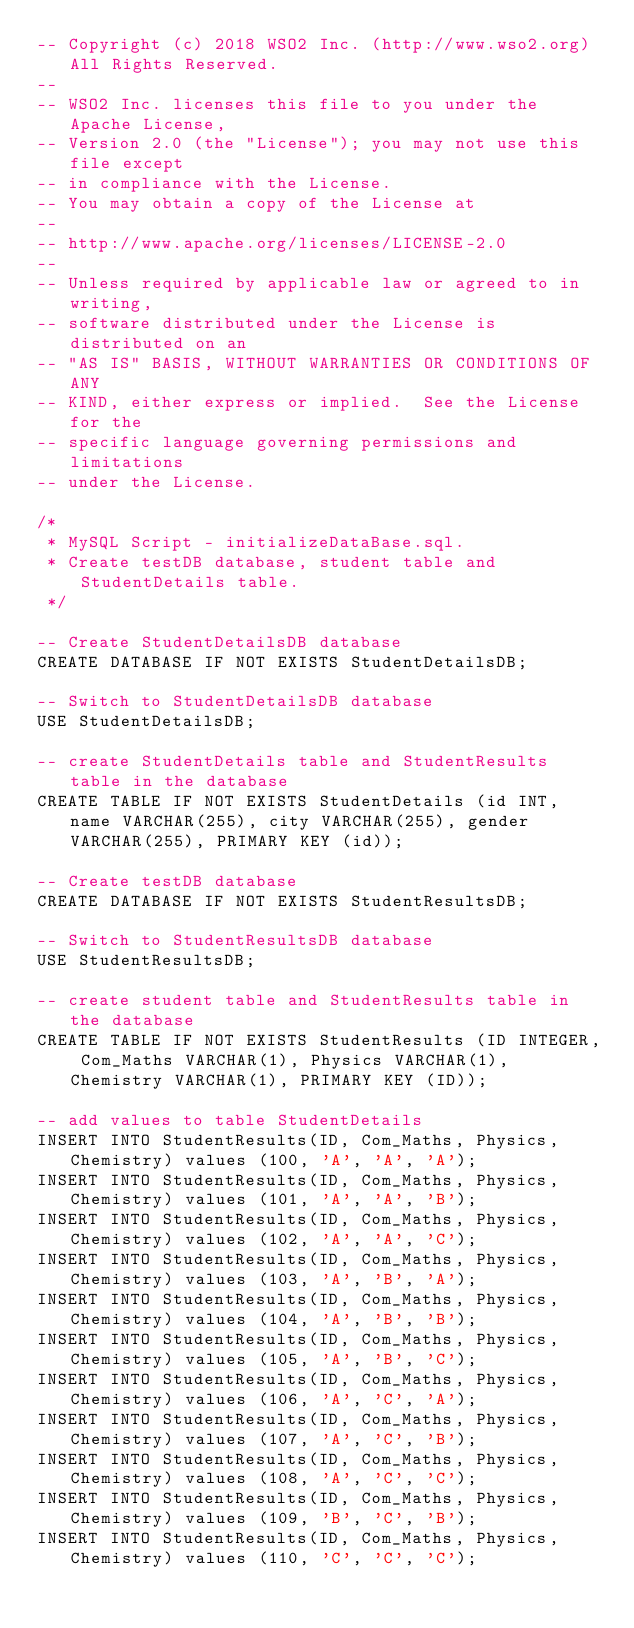<code> <loc_0><loc_0><loc_500><loc_500><_SQL_>-- Copyright (c) 2018 WSO2 Inc. (http://www.wso2.org) All Rights Reserved.
--
-- WSO2 Inc. licenses this file to you under the Apache License,
-- Version 2.0 (the "License"); you may not use this file except
-- in compliance with the License.
-- You may obtain a copy of the License at
--
-- http://www.apache.org/licenses/LICENSE-2.0
--
-- Unless required by applicable law or agreed to in writing,
-- software distributed under the License is distributed on an
-- "AS IS" BASIS, WITHOUT WARRANTIES OR CONDITIONS OF ANY
-- KIND, either express or implied.  See the License for the
-- specific language governing permissions and limitations
-- under the License.

/* 
 * MySQL Script - initializeDataBase.sql.
 * Create testDB database, student table and StudentDetails table.
 */
 
-- Create StudentDetailsDB database
CREATE DATABASE IF NOT EXISTS StudentDetailsDB;

-- Switch to StudentDetailsDB database
USE StudentDetailsDB;

-- create StudentDetails table and StudentResults table in the database
CREATE TABLE IF NOT EXISTS StudentDetails (id INT, name VARCHAR(255), city VARCHAR(255), gender VARCHAR(255), PRIMARY KEY (id));

-- Create testDB database
CREATE DATABASE IF NOT EXISTS StudentResultsDB;

-- Switch to StudentResultsDB database
USE StudentResultsDB;

-- create student table and StudentResults table in the database
CREATE TABLE IF NOT EXISTS StudentResults (ID INTEGER, Com_Maths VARCHAR(1), Physics VARCHAR(1), Chemistry VARCHAR(1), PRIMARY KEY (ID));

-- add values to table StudentDetails
INSERT INTO StudentResults(ID, Com_Maths, Physics, Chemistry) values (100, 'A', 'A', 'A');
INSERT INTO StudentResults(ID, Com_Maths, Physics, Chemistry) values (101, 'A', 'A', 'B');
INSERT INTO StudentResults(ID, Com_Maths, Physics, Chemistry) values (102, 'A', 'A', 'C');
INSERT INTO StudentResults(ID, Com_Maths, Physics, Chemistry) values (103, 'A', 'B', 'A');
INSERT INTO StudentResults(ID, Com_Maths, Physics, Chemistry) values (104, 'A', 'B', 'B');
INSERT INTO StudentResults(ID, Com_Maths, Physics, Chemistry) values (105, 'A', 'B', 'C');
INSERT INTO StudentResults(ID, Com_Maths, Physics, Chemistry) values (106, 'A', 'C', 'A');
INSERT INTO StudentResults(ID, Com_Maths, Physics, Chemistry) values (107, 'A', 'C', 'B');
INSERT INTO StudentResults(ID, Com_Maths, Physics, Chemistry) values (108, 'A', 'C', 'C');
INSERT INTO StudentResults(ID, Com_Maths, Physics, Chemistry) values (109, 'B', 'C', 'B');
INSERT INTO StudentResults(ID, Com_Maths, Physics, Chemistry) values (110, 'C', 'C', 'C');
</code> 